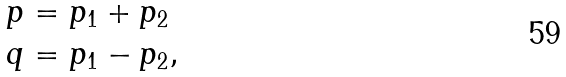Convert formula to latex. <formula><loc_0><loc_0><loc_500><loc_500>p & = p _ { 1 } + p _ { 2 } \\ q & = p _ { 1 } - p _ { 2 } ,</formula> 